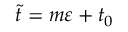<formula> <loc_0><loc_0><loc_500><loc_500>\tilde { t } = m \varepsilon + t _ { 0 }</formula> 